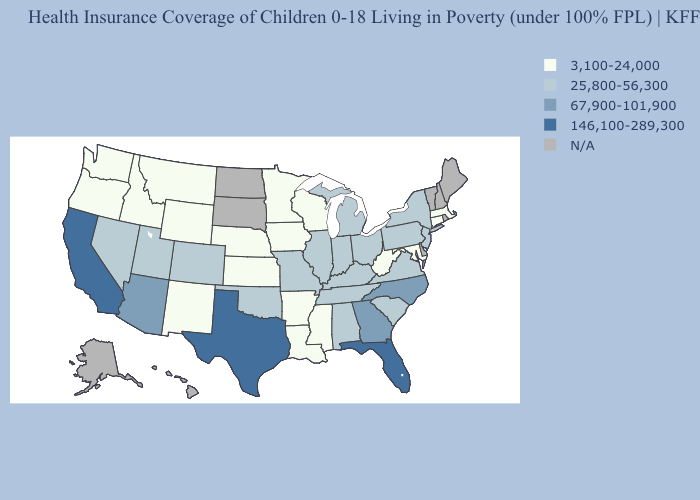What is the highest value in states that border Tennessee?
Keep it brief. 67,900-101,900. What is the highest value in the Northeast ?
Be succinct. 25,800-56,300. What is the value of Indiana?
Keep it brief. 25,800-56,300. Among the states that border New Mexico , which have the lowest value?
Concise answer only. Colorado, Oklahoma, Utah. Which states have the lowest value in the West?
Give a very brief answer. Idaho, Montana, New Mexico, Oregon, Washington, Wyoming. Which states have the lowest value in the USA?
Keep it brief. Arkansas, Connecticut, Idaho, Iowa, Kansas, Louisiana, Maryland, Massachusetts, Minnesota, Mississippi, Montana, Nebraska, New Mexico, Oregon, Washington, West Virginia, Wisconsin, Wyoming. What is the value of Michigan?
Answer briefly. 25,800-56,300. What is the highest value in the South ?
Short answer required. 146,100-289,300. What is the value of South Dakota?
Give a very brief answer. N/A. Does South Carolina have the highest value in the USA?
Be succinct. No. Which states have the highest value in the USA?
Keep it brief. California, Florida, Texas. What is the lowest value in the MidWest?
Be succinct. 3,100-24,000. Does the map have missing data?
Quick response, please. Yes. 